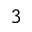<formula> <loc_0><loc_0><loc_500><loc_500>_ { 3 }</formula> 